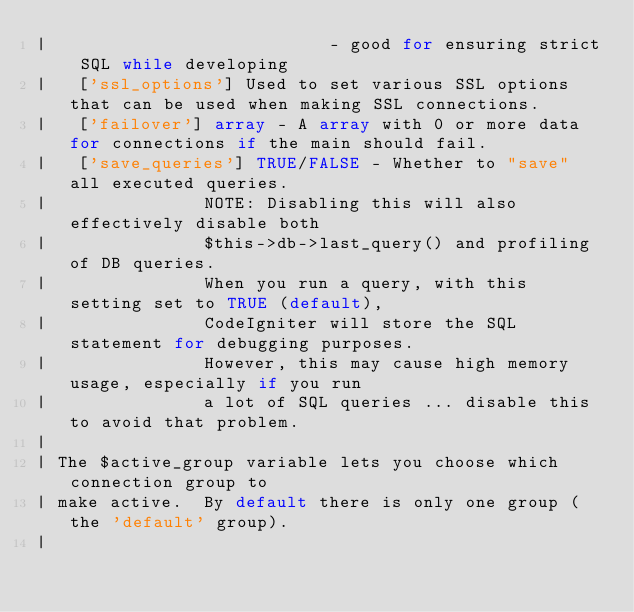Convert code to text. <code><loc_0><loc_0><loc_500><loc_500><_PHP_>|							- good for ensuring strict SQL while developing
|	['ssl_options']	Used to set various SSL options that can be used when making SSL connections.
|	['failover'] array - A array with 0 or more data for connections if the main should fail.
|	['save_queries'] TRUE/FALSE - Whether to "save" all executed queries.
| 				NOTE: Disabling this will also effectively disable both
| 				$this->db->last_query() and profiling of DB queries.
| 				When you run a query, with this setting set to TRUE (default),
| 				CodeIgniter will store the SQL statement for debugging purposes.
| 				However, this may cause high memory usage, especially if you run
| 				a lot of SQL queries ... disable this to avoid that problem.
|
| The $active_group variable lets you choose which connection group to
| make active.  By default there is only one group (the 'default' group).
|</code> 